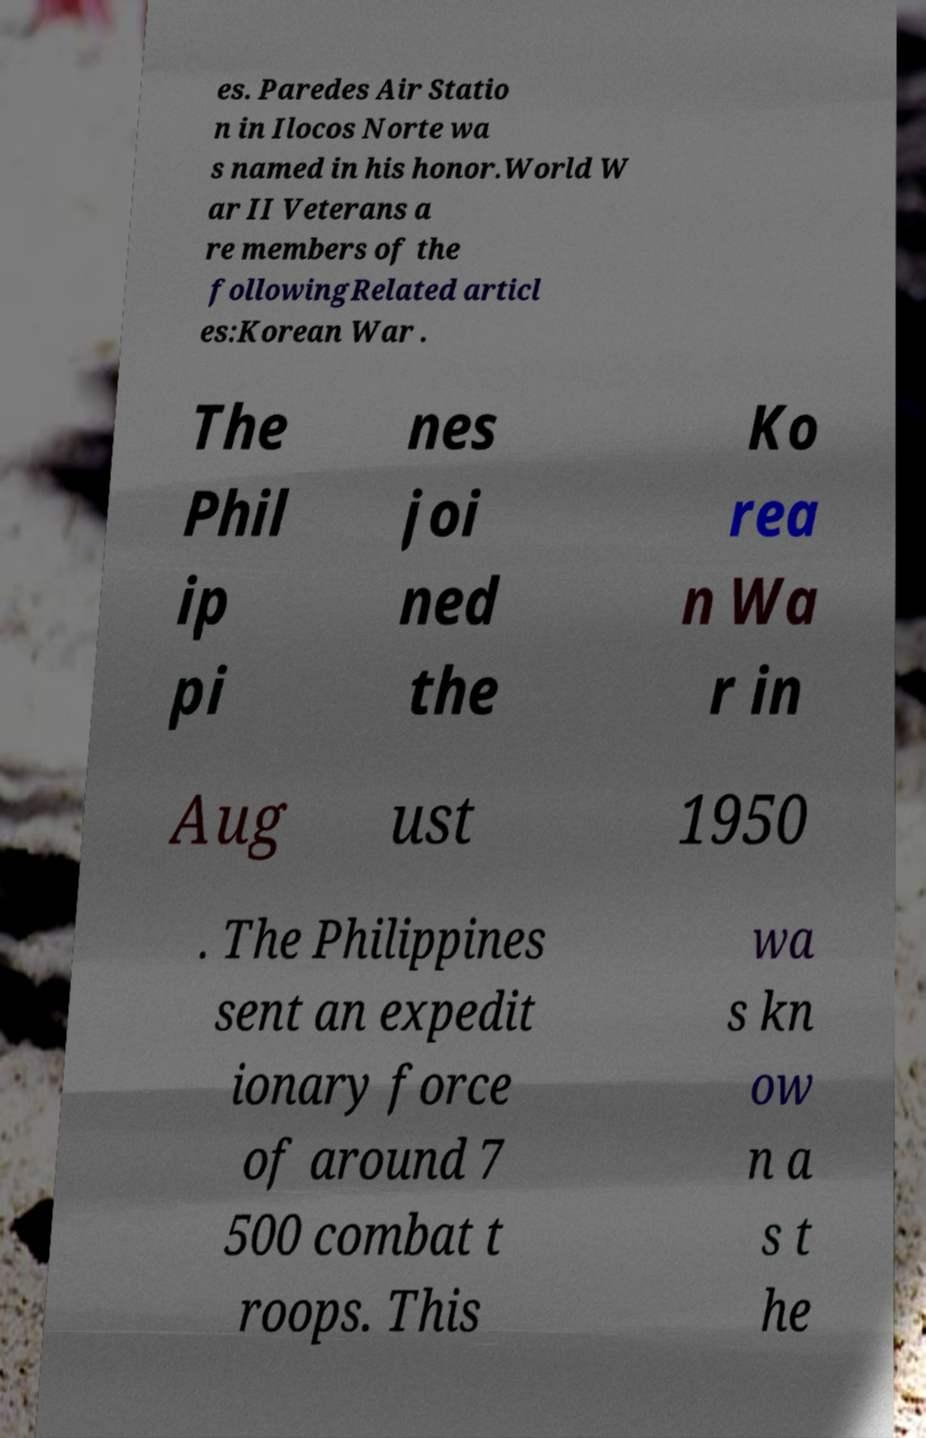Could you assist in decoding the text presented in this image and type it out clearly? es. Paredes Air Statio n in Ilocos Norte wa s named in his honor.World W ar II Veterans a re members of the followingRelated articl es:Korean War . The Phil ip pi nes joi ned the Ko rea n Wa r in Aug ust 1950 . The Philippines sent an expedit ionary force of around 7 500 combat t roops. This wa s kn ow n a s t he 